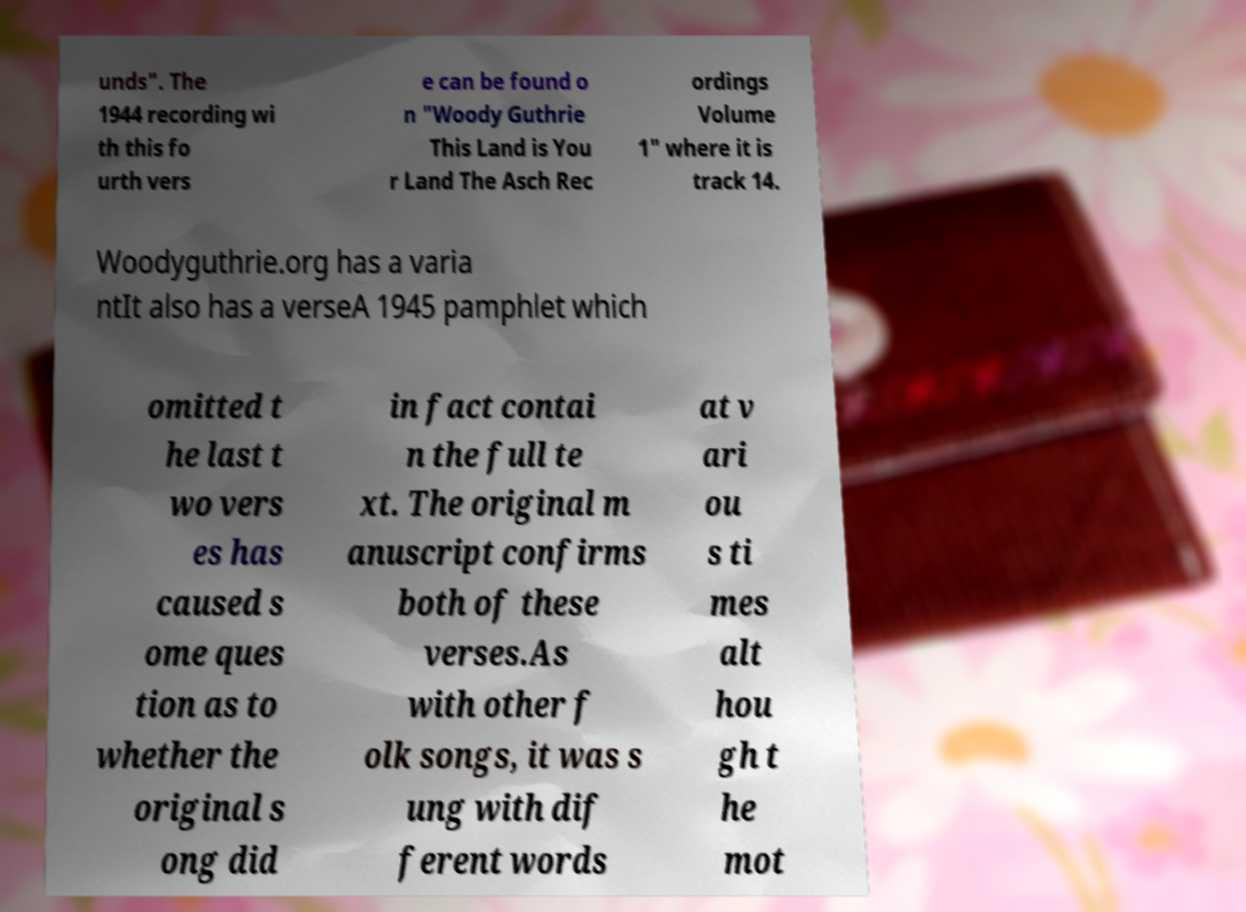I need the written content from this picture converted into text. Can you do that? unds". The 1944 recording wi th this fo urth vers e can be found o n "Woody Guthrie This Land is You r Land The Asch Rec ordings Volume 1" where it is track 14. Woodyguthrie.org has a varia ntIt also has a verseA 1945 pamphlet which omitted t he last t wo vers es has caused s ome ques tion as to whether the original s ong did in fact contai n the full te xt. The original m anuscript confirms both of these verses.As with other f olk songs, it was s ung with dif ferent words at v ari ou s ti mes alt hou gh t he mot 